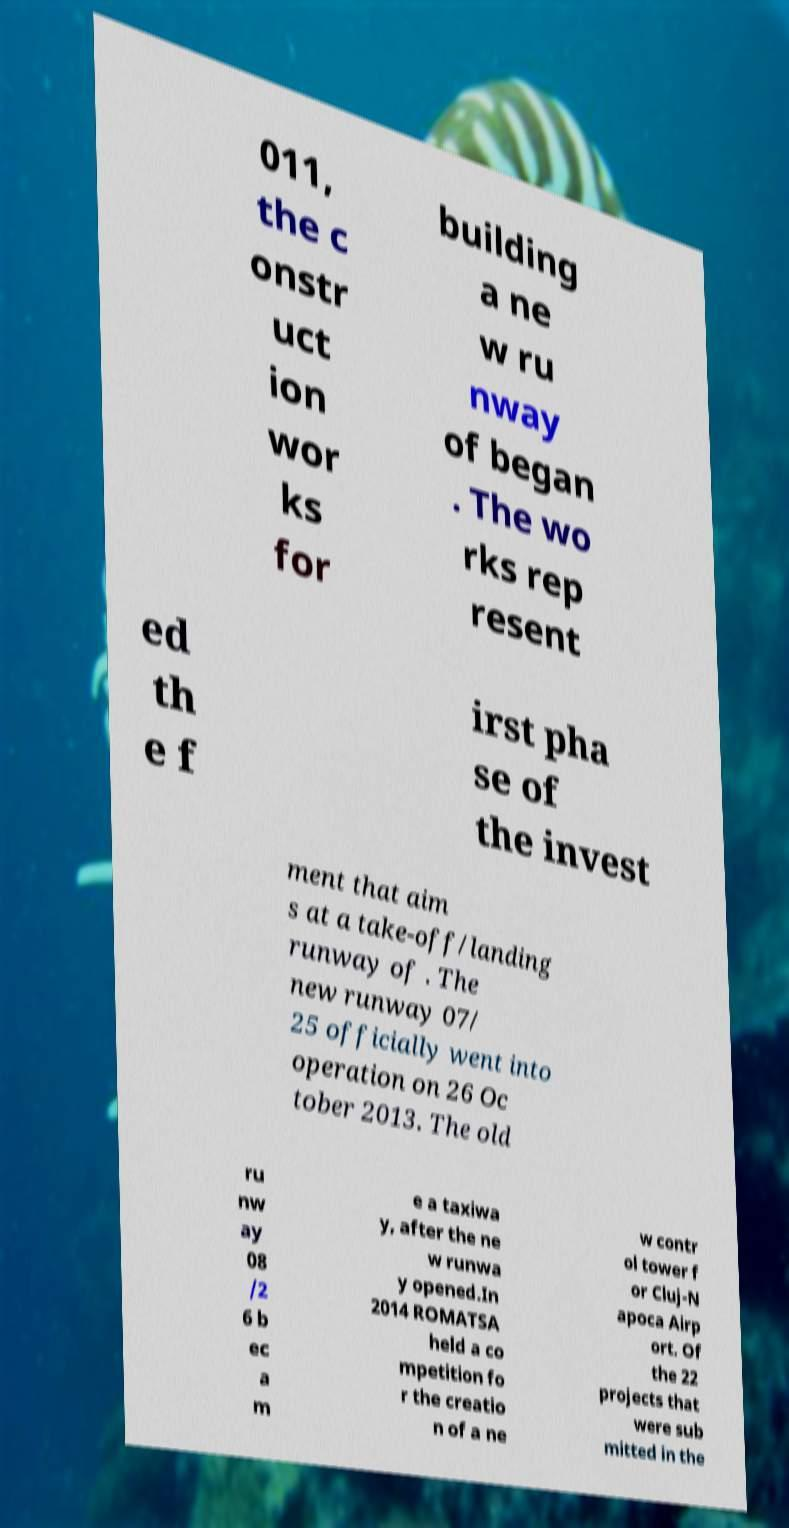Can you accurately transcribe the text from the provided image for me? 011, the c onstr uct ion wor ks for building a ne w ru nway of began . The wo rks rep resent ed th e f irst pha se of the invest ment that aim s at a take-off/landing runway of . The new runway 07/ 25 officially went into operation on 26 Oc tober 2013. The old ru nw ay 08 /2 6 b ec a m e a taxiwa y, after the ne w runwa y opened.In 2014 ROMATSA held a co mpetition fo r the creatio n of a ne w contr ol tower f or Cluj-N apoca Airp ort. Of the 22 projects that were sub mitted in the 